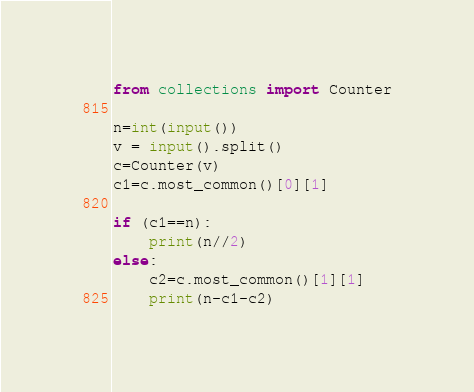Convert code to text. <code><loc_0><loc_0><loc_500><loc_500><_Python_>from collections import Counter

n=int(input())
v = input().split()
c=Counter(v)
c1=c.most_common()[0][1]

if (c1==n):
    print(n//2)
else:
    c2=c.most_common()[1][1]
    print(n-c1-c2)</code> 